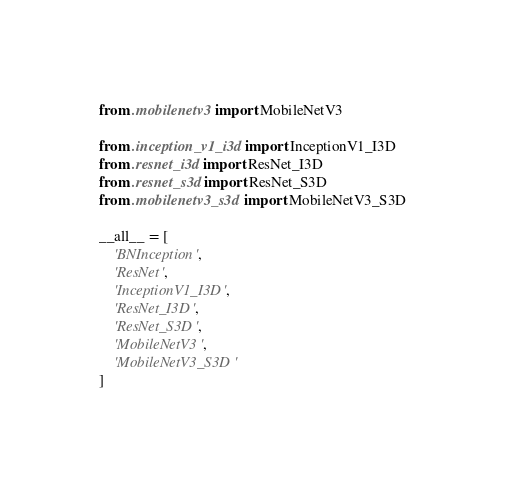Convert code to text. <code><loc_0><loc_0><loc_500><loc_500><_Python_>from .mobilenetv3 import MobileNetV3

from .inception_v1_i3d import InceptionV1_I3D
from .resnet_i3d import ResNet_I3D
from .resnet_s3d import ResNet_S3D
from .mobilenetv3_s3d import MobileNetV3_S3D

__all__ = [
    'BNInception',
    'ResNet',
    'InceptionV1_I3D',
    'ResNet_I3D',
    'ResNet_S3D',
    'MobileNetV3',
    'MobileNetV3_S3D'
]
</code> 